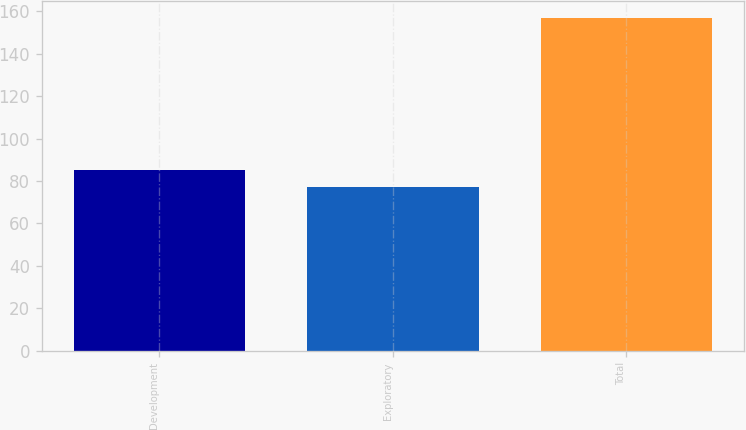Convert chart. <chart><loc_0><loc_0><loc_500><loc_500><bar_chart><fcel>Development<fcel>Exploratory<fcel>Total<nl><fcel>85<fcel>77<fcel>157<nl></chart> 